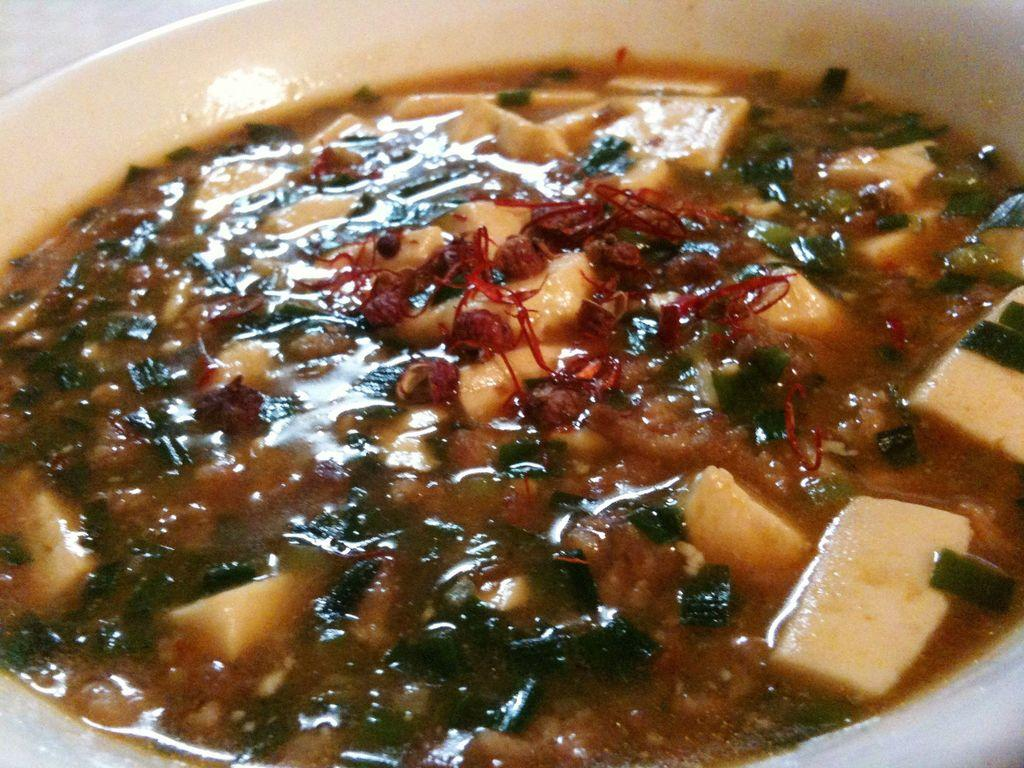What is in the bowl that is visible in the image? There is food in a bowl in the image. How many babies are present in the image? There are no babies present in the image; it only features a bowl of food. Is there a club mentioned or depicted in the image? There is no mention or depiction of a club in the image. 